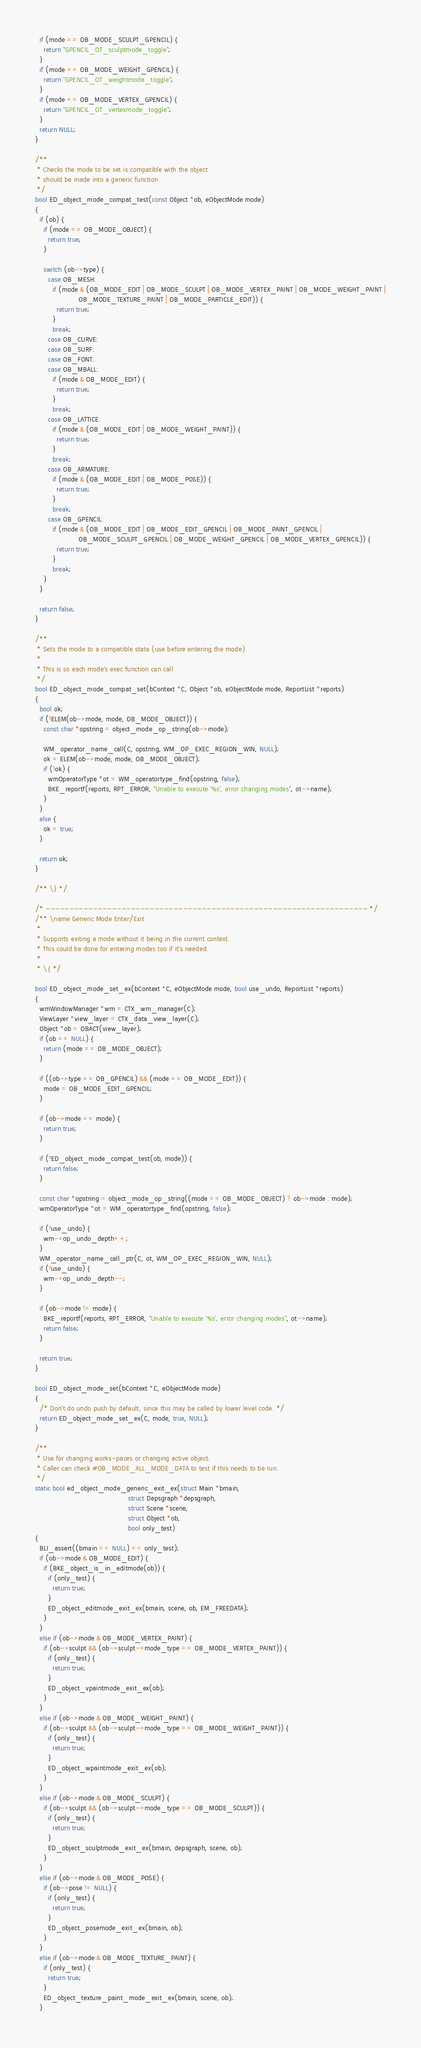<code> <loc_0><loc_0><loc_500><loc_500><_C_>  if (mode == OB_MODE_SCULPT_GPENCIL) {
    return "GPENCIL_OT_sculptmode_toggle";
  }
  if (mode == OB_MODE_WEIGHT_GPENCIL) {
    return "GPENCIL_OT_weightmode_toggle";
  }
  if (mode == OB_MODE_VERTEX_GPENCIL) {
    return "GPENCIL_OT_vertexmode_toggle";
  }
  return NULL;
}

/**
 * Checks the mode to be set is compatible with the object
 * should be made into a generic function
 */
bool ED_object_mode_compat_test(const Object *ob, eObjectMode mode)
{
  if (ob) {
    if (mode == OB_MODE_OBJECT) {
      return true;
    }

    switch (ob->type) {
      case OB_MESH:
        if (mode & (OB_MODE_EDIT | OB_MODE_SCULPT | OB_MODE_VERTEX_PAINT | OB_MODE_WEIGHT_PAINT |
                    OB_MODE_TEXTURE_PAINT | OB_MODE_PARTICLE_EDIT)) {
          return true;
        }
        break;
      case OB_CURVE:
      case OB_SURF:
      case OB_FONT:
      case OB_MBALL:
        if (mode & OB_MODE_EDIT) {
          return true;
        }
        break;
      case OB_LATTICE:
        if (mode & (OB_MODE_EDIT | OB_MODE_WEIGHT_PAINT)) {
          return true;
        }
        break;
      case OB_ARMATURE:
        if (mode & (OB_MODE_EDIT | OB_MODE_POSE)) {
          return true;
        }
        break;
      case OB_GPENCIL:
        if (mode & (OB_MODE_EDIT | OB_MODE_EDIT_GPENCIL | OB_MODE_PAINT_GPENCIL |
                    OB_MODE_SCULPT_GPENCIL | OB_MODE_WEIGHT_GPENCIL | OB_MODE_VERTEX_GPENCIL)) {
          return true;
        }
        break;
    }
  }

  return false;
}

/**
 * Sets the mode to a compatible state (use before entering the mode).
 *
 * This is so each mode's exec function can call
 */
bool ED_object_mode_compat_set(bContext *C, Object *ob, eObjectMode mode, ReportList *reports)
{
  bool ok;
  if (!ELEM(ob->mode, mode, OB_MODE_OBJECT)) {
    const char *opstring = object_mode_op_string(ob->mode);

    WM_operator_name_call(C, opstring, WM_OP_EXEC_REGION_WIN, NULL);
    ok = ELEM(ob->mode, mode, OB_MODE_OBJECT);
    if (!ok) {
      wmOperatorType *ot = WM_operatortype_find(opstring, false);
      BKE_reportf(reports, RPT_ERROR, "Unable to execute '%s', error changing modes", ot->name);
    }
  }
  else {
    ok = true;
  }

  return ok;
}

/** \} */

/* -------------------------------------------------------------------- */
/** \name Generic Mode Enter/Exit
 *
 * Supports exiting a mode without it being in the current context.
 * This could be done for entering modes too if it's needed.
 *
 * \{ */

bool ED_object_mode_set_ex(bContext *C, eObjectMode mode, bool use_undo, ReportList *reports)
{
  wmWindowManager *wm = CTX_wm_manager(C);
  ViewLayer *view_layer = CTX_data_view_layer(C);
  Object *ob = OBACT(view_layer);
  if (ob == NULL) {
    return (mode == OB_MODE_OBJECT);
  }

  if ((ob->type == OB_GPENCIL) && (mode == OB_MODE_EDIT)) {
    mode = OB_MODE_EDIT_GPENCIL;
  }

  if (ob->mode == mode) {
    return true;
  }

  if (!ED_object_mode_compat_test(ob, mode)) {
    return false;
  }

  const char *opstring = object_mode_op_string((mode == OB_MODE_OBJECT) ? ob->mode : mode);
  wmOperatorType *ot = WM_operatortype_find(opstring, false);

  if (!use_undo) {
    wm->op_undo_depth++;
  }
  WM_operator_name_call_ptr(C, ot, WM_OP_EXEC_REGION_WIN, NULL);
  if (!use_undo) {
    wm->op_undo_depth--;
  }

  if (ob->mode != mode) {
    BKE_reportf(reports, RPT_ERROR, "Unable to execute '%s', error changing modes", ot->name);
    return false;
  }

  return true;
}

bool ED_object_mode_set(bContext *C, eObjectMode mode)
{
  /* Don't do undo push by default, since this may be called by lower level code. */
  return ED_object_mode_set_ex(C, mode, true, NULL);
}

/**
 * Use for changing works-paces or changing active object.
 * Caller can check #OB_MODE_ALL_MODE_DATA to test if this needs to be run.
 */
static bool ed_object_mode_generic_exit_ex(struct Main *bmain,
                                           struct Depsgraph *depsgraph,
                                           struct Scene *scene,
                                           struct Object *ob,
                                           bool only_test)
{
  BLI_assert((bmain == NULL) == only_test);
  if (ob->mode & OB_MODE_EDIT) {
    if (BKE_object_is_in_editmode(ob)) {
      if (only_test) {
        return true;
      }
      ED_object_editmode_exit_ex(bmain, scene, ob, EM_FREEDATA);
    }
  }
  else if (ob->mode & OB_MODE_VERTEX_PAINT) {
    if (ob->sculpt && (ob->sculpt->mode_type == OB_MODE_VERTEX_PAINT)) {
      if (only_test) {
        return true;
      }
      ED_object_vpaintmode_exit_ex(ob);
    }
  }
  else if (ob->mode & OB_MODE_WEIGHT_PAINT) {
    if (ob->sculpt && (ob->sculpt->mode_type == OB_MODE_WEIGHT_PAINT)) {
      if (only_test) {
        return true;
      }
      ED_object_wpaintmode_exit_ex(ob);
    }
  }
  else if (ob->mode & OB_MODE_SCULPT) {
    if (ob->sculpt && (ob->sculpt->mode_type == OB_MODE_SCULPT)) {
      if (only_test) {
        return true;
      }
      ED_object_sculptmode_exit_ex(bmain, depsgraph, scene, ob);
    }
  }
  else if (ob->mode & OB_MODE_POSE) {
    if (ob->pose != NULL) {
      if (only_test) {
        return true;
      }
      ED_object_posemode_exit_ex(bmain, ob);
    }
  }
  else if (ob->mode & OB_MODE_TEXTURE_PAINT) {
    if (only_test) {
      return true;
    }
    ED_object_texture_paint_mode_exit_ex(bmain, scene, ob);
  }</code> 